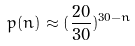Convert formula to latex. <formula><loc_0><loc_0><loc_500><loc_500>p ( n ) \approx ( \frac { 2 0 } { 3 0 } ) ^ { 3 0 - n }</formula> 